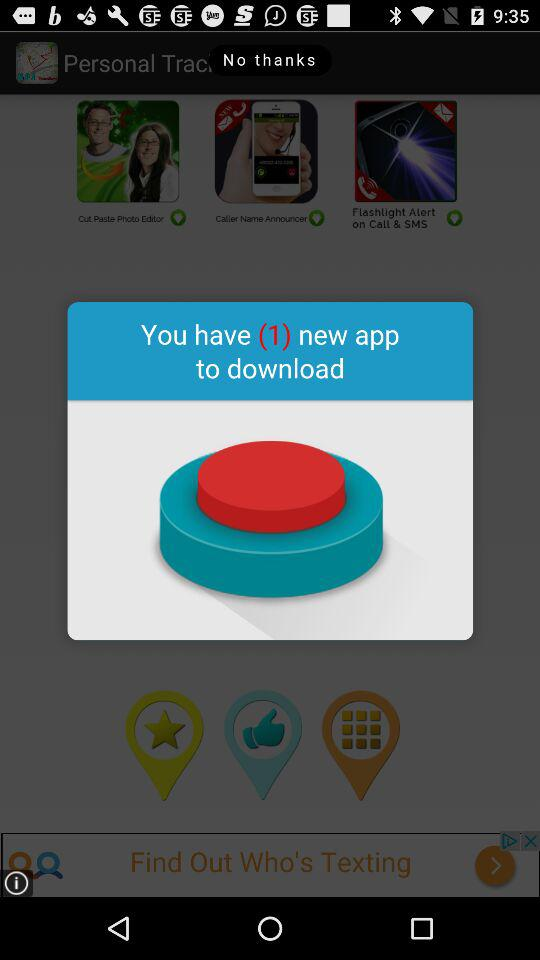How many new apps are there to download? There is 1 new app to download. 